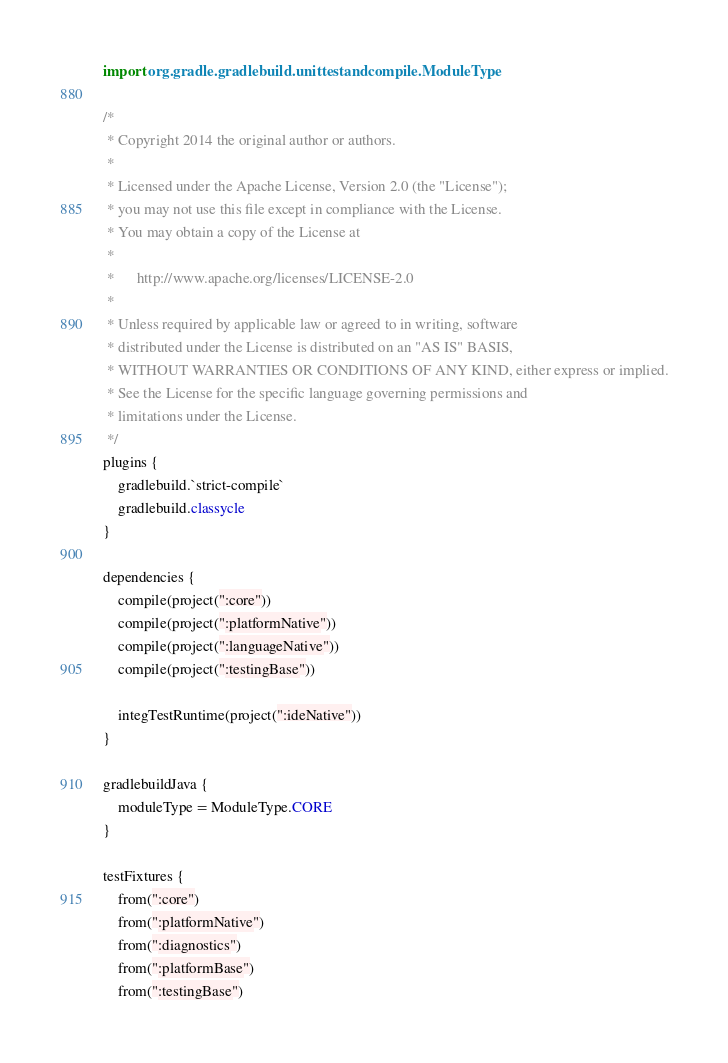Convert code to text. <code><loc_0><loc_0><loc_500><loc_500><_Kotlin_>import org.gradle.gradlebuild.unittestandcompile.ModuleType

/*
 * Copyright 2014 the original author or authors.
 *
 * Licensed under the Apache License, Version 2.0 (the "License");
 * you may not use this file except in compliance with the License.
 * You may obtain a copy of the License at
 *
 *      http://www.apache.org/licenses/LICENSE-2.0
 *
 * Unless required by applicable law or agreed to in writing, software
 * distributed under the License is distributed on an "AS IS" BASIS,
 * WITHOUT WARRANTIES OR CONDITIONS OF ANY KIND, either express or implied.
 * See the License for the specific language governing permissions and
 * limitations under the License.
 */
plugins {
    gradlebuild.`strict-compile`
    gradlebuild.classycle
}

dependencies {
    compile(project(":core"))
    compile(project(":platformNative"))
    compile(project(":languageNative"))
    compile(project(":testingBase"))

    integTestRuntime(project(":ideNative"))
}

gradlebuildJava {
    moduleType = ModuleType.CORE
}

testFixtures {
    from(":core")
    from(":platformNative")
    from(":diagnostics")
    from(":platformBase")
    from(":testingBase")</code> 